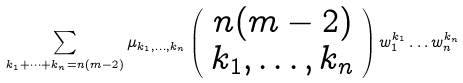<formula> <loc_0><loc_0><loc_500><loc_500>\sum _ { k _ { 1 } + \dots + k _ { n } = n ( m - 2 ) } \mu _ { k _ { 1 } , \dots , k _ { n } } \left ( \begin{array} { c } n ( m - 2 ) \\ k _ { 1 } , \dots , k _ { n } \end{array} \right ) w _ { 1 } ^ { k _ { 1 } } \dots w _ { n } ^ { k _ { n } }</formula> 